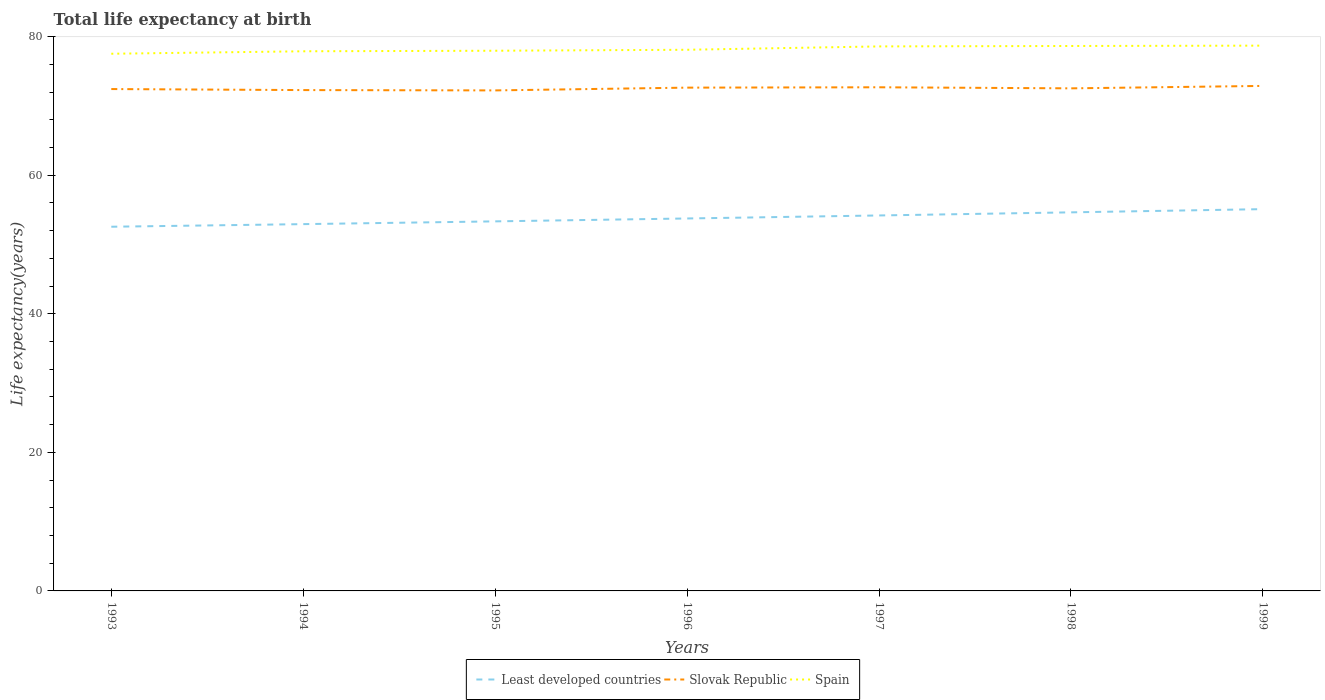Does the line corresponding to Slovak Republic intersect with the line corresponding to Least developed countries?
Give a very brief answer. No. Is the number of lines equal to the number of legend labels?
Your response must be concise. Yes. Across all years, what is the maximum life expectancy at birth in in Spain?
Your answer should be compact. 77.55. What is the total life expectancy at birth in in Least developed countries in the graph?
Make the answer very short. -1.77. What is the difference between the highest and the second highest life expectancy at birth in in Spain?
Offer a terse response. 1.17. Is the life expectancy at birth in in Spain strictly greater than the life expectancy at birth in in Least developed countries over the years?
Provide a short and direct response. No. How many lines are there?
Provide a succinct answer. 3. What is the difference between two consecutive major ticks on the Y-axis?
Keep it short and to the point. 20. How are the legend labels stacked?
Provide a short and direct response. Horizontal. What is the title of the graph?
Your answer should be very brief. Total life expectancy at birth. Does "Afghanistan" appear as one of the legend labels in the graph?
Keep it short and to the point. No. What is the label or title of the X-axis?
Ensure brevity in your answer.  Years. What is the label or title of the Y-axis?
Keep it short and to the point. Life expectancy(years). What is the Life expectancy(years) in Least developed countries in 1993?
Your answer should be very brief. 52.57. What is the Life expectancy(years) in Slovak Republic in 1993?
Offer a very short reply. 72.45. What is the Life expectancy(years) of Spain in 1993?
Your answer should be very brief. 77.55. What is the Life expectancy(years) in Least developed countries in 1994?
Give a very brief answer. 52.95. What is the Life expectancy(years) in Slovak Republic in 1994?
Your response must be concise. 72.3. What is the Life expectancy(years) in Spain in 1994?
Make the answer very short. 77.9. What is the Life expectancy(years) in Least developed countries in 1995?
Your answer should be compact. 53.35. What is the Life expectancy(years) of Slovak Republic in 1995?
Your answer should be compact. 72.25. What is the Life expectancy(years) of Spain in 1995?
Provide a short and direct response. 77.98. What is the Life expectancy(years) of Least developed countries in 1996?
Your response must be concise. 53.77. What is the Life expectancy(years) of Slovak Republic in 1996?
Your answer should be compact. 72.65. What is the Life expectancy(years) of Spain in 1996?
Make the answer very short. 78.12. What is the Life expectancy(years) of Least developed countries in 1997?
Provide a short and direct response. 54.2. What is the Life expectancy(years) of Slovak Republic in 1997?
Your response must be concise. 72.7. What is the Life expectancy(years) of Spain in 1997?
Your answer should be very brief. 78.6. What is the Life expectancy(years) in Least developed countries in 1998?
Your answer should be compact. 54.65. What is the Life expectancy(years) of Slovak Republic in 1998?
Your response must be concise. 72.55. What is the Life expectancy(years) of Spain in 1998?
Offer a terse response. 78.67. What is the Life expectancy(years) of Least developed countries in 1999?
Keep it short and to the point. 55.11. What is the Life expectancy(years) in Slovak Republic in 1999?
Ensure brevity in your answer.  72.9. What is the Life expectancy(years) in Spain in 1999?
Provide a succinct answer. 78.72. Across all years, what is the maximum Life expectancy(years) of Least developed countries?
Give a very brief answer. 55.11. Across all years, what is the maximum Life expectancy(years) of Slovak Republic?
Ensure brevity in your answer.  72.9. Across all years, what is the maximum Life expectancy(years) in Spain?
Ensure brevity in your answer.  78.72. Across all years, what is the minimum Life expectancy(years) of Least developed countries?
Your answer should be very brief. 52.57. Across all years, what is the minimum Life expectancy(years) of Slovak Republic?
Offer a very short reply. 72.25. Across all years, what is the minimum Life expectancy(years) of Spain?
Ensure brevity in your answer.  77.55. What is the total Life expectancy(years) in Least developed countries in the graph?
Ensure brevity in your answer.  376.6. What is the total Life expectancy(years) of Slovak Republic in the graph?
Offer a very short reply. 507.81. What is the total Life expectancy(years) of Spain in the graph?
Keep it short and to the point. 547.54. What is the difference between the Life expectancy(years) in Least developed countries in 1993 and that in 1994?
Your answer should be very brief. -0.38. What is the difference between the Life expectancy(years) in Slovak Republic in 1993 and that in 1994?
Give a very brief answer. 0.15. What is the difference between the Life expectancy(years) in Spain in 1993 and that in 1994?
Keep it short and to the point. -0.35. What is the difference between the Life expectancy(years) of Least developed countries in 1993 and that in 1995?
Keep it short and to the point. -0.77. What is the difference between the Life expectancy(years) in Slovak Republic in 1993 and that in 1995?
Your response must be concise. 0.2. What is the difference between the Life expectancy(years) of Spain in 1993 and that in 1995?
Your answer should be very brief. -0.43. What is the difference between the Life expectancy(years) in Least developed countries in 1993 and that in 1996?
Provide a succinct answer. -1.19. What is the difference between the Life expectancy(years) of Slovak Republic in 1993 and that in 1996?
Provide a succinct answer. -0.2. What is the difference between the Life expectancy(years) in Spain in 1993 and that in 1996?
Your response must be concise. -0.57. What is the difference between the Life expectancy(years) of Least developed countries in 1993 and that in 1997?
Offer a very short reply. -1.63. What is the difference between the Life expectancy(years) in Slovak Republic in 1993 and that in 1997?
Your answer should be compact. -0.26. What is the difference between the Life expectancy(years) of Spain in 1993 and that in 1997?
Your answer should be very brief. -1.06. What is the difference between the Life expectancy(years) in Least developed countries in 1993 and that in 1998?
Offer a very short reply. -2.08. What is the difference between the Life expectancy(years) of Slovak Republic in 1993 and that in 1998?
Ensure brevity in your answer.  -0.1. What is the difference between the Life expectancy(years) of Spain in 1993 and that in 1998?
Offer a terse response. -1.12. What is the difference between the Life expectancy(years) in Least developed countries in 1993 and that in 1999?
Give a very brief answer. -2.54. What is the difference between the Life expectancy(years) of Slovak Republic in 1993 and that in 1999?
Give a very brief answer. -0.45. What is the difference between the Life expectancy(years) in Spain in 1993 and that in 1999?
Provide a short and direct response. -1.17. What is the difference between the Life expectancy(years) of Least developed countries in 1994 and that in 1995?
Your answer should be very brief. -0.4. What is the difference between the Life expectancy(years) of Slovak Republic in 1994 and that in 1995?
Offer a very short reply. 0.05. What is the difference between the Life expectancy(years) in Spain in 1994 and that in 1995?
Ensure brevity in your answer.  -0.08. What is the difference between the Life expectancy(years) in Least developed countries in 1994 and that in 1996?
Offer a terse response. -0.82. What is the difference between the Life expectancy(years) of Slovak Republic in 1994 and that in 1996?
Your answer should be compact. -0.35. What is the difference between the Life expectancy(years) of Spain in 1994 and that in 1996?
Make the answer very short. -0.22. What is the difference between the Life expectancy(years) of Least developed countries in 1994 and that in 1997?
Give a very brief answer. -1.25. What is the difference between the Life expectancy(years) of Slovak Republic in 1994 and that in 1997?
Offer a very short reply. -0.4. What is the difference between the Life expectancy(years) of Spain in 1994 and that in 1997?
Offer a very short reply. -0.7. What is the difference between the Life expectancy(years) in Least developed countries in 1994 and that in 1998?
Your response must be concise. -1.7. What is the difference between the Life expectancy(years) in Slovak Republic in 1994 and that in 1998?
Provide a short and direct response. -0.25. What is the difference between the Life expectancy(years) in Spain in 1994 and that in 1998?
Ensure brevity in your answer.  -0.76. What is the difference between the Life expectancy(years) in Least developed countries in 1994 and that in 1999?
Keep it short and to the point. -2.16. What is the difference between the Life expectancy(years) of Slovak Republic in 1994 and that in 1999?
Offer a very short reply. -0.6. What is the difference between the Life expectancy(years) in Spain in 1994 and that in 1999?
Offer a very short reply. -0.82. What is the difference between the Life expectancy(years) in Least developed countries in 1995 and that in 1996?
Ensure brevity in your answer.  -0.42. What is the difference between the Life expectancy(years) of Spain in 1995 and that in 1996?
Your response must be concise. -0.14. What is the difference between the Life expectancy(years) in Least developed countries in 1995 and that in 1997?
Your answer should be very brief. -0.85. What is the difference between the Life expectancy(years) of Slovak Republic in 1995 and that in 1997?
Your answer should be compact. -0.45. What is the difference between the Life expectancy(years) of Spain in 1995 and that in 1997?
Provide a succinct answer. -0.62. What is the difference between the Life expectancy(years) in Least developed countries in 1995 and that in 1998?
Your response must be concise. -1.3. What is the difference between the Life expectancy(years) in Slovak Republic in 1995 and that in 1998?
Ensure brevity in your answer.  -0.3. What is the difference between the Life expectancy(years) of Spain in 1995 and that in 1998?
Ensure brevity in your answer.  -0.69. What is the difference between the Life expectancy(years) of Least developed countries in 1995 and that in 1999?
Your answer should be compact. -1.77. What is the difference between the Life expectancy(years) of Slovak Republic in 1995 and that in 1999?
Offer a very short reply. -0.65. What is the difference between the Life expectancy(years) of Spain in 1995 and that in 1999?
Ensure brevity in your answer.  -0.74. What is the difference between the Life expectancy(years) of Least developed countries in 1996 and that in 1997?
Offer a very short reply. -0.43. What is the difference between the Life expectancy(years) of Slovak Republic in 1996 and that in 1997?
Provide a short and direct response. -0.05. What is the difference between the Life expectancy(years) in Spain in 1996 and that in 1997?
Your response must be concise. -0.48. What is the difference between the Life expectancy(years) of Least developed countries in 1996 and that in 1998?
Keep it short and to the point. -0.88. What is the difference between the Life expectancy(years) in Slovak Republic in 1996 and that in 1998?
Make the answer very short. 0.1. What is the difference between the Life expectancy(years) in Spain in 1996 and that in 1998?
Keep it short and to the point. -0.55. What is the difference between the Life expectancy(years) in Least developed countries in 1996 and that in 1999?
Keep it short and to the point. -1.35. What is the difference between the Life expectancy(years) in Slovak Republic in 1996 and that in 1999?
Provide a succinct answer. -0.25. What is the difference between the Life expectancy(years) in Spain in 1996 and that in 1999?
Provide a succinct answer. -0.6. What is the difference between the Life expectancy(years) in Least developed countries in 1997 and that in 1998?
Make the answer very short. -0.45. What is the difference between the Life expectancy(years) of Slovak Republic in 1997 and that in 1998?
Make the answer very short. 0.15. What is the difference between the Life expectancy(years) of Spain in 1997 and that in 1998?
Offer a very short reply. -0.06. What is the difference between the Life expectancy(years) of Least developed countries in 1997 and that in 1999?
Offer a terse response. -0.91. What is the difference between the Life expectancy(years) in Slovak Republic in 1997 and that in 1999?
Give a very brief answer. -0.2. What is the difference between the Life expectancy(years) in Spain in 1997 and that in 1999?
Ensure brevity in your answer.  -0.11. What is the difference between the Life expectancy(years) of Least developed countries in 1998 and that in 1999?
Offer a terse response. -0.46. What is the difference between the Life expectancy(years) of Slovak Republic in 1998 and that in 1999?
Ensure brevity in your answer.  -0.35. What is the difference between the Life expectancy(years) in Spain in 1998 and that in 1999?
Offer a very short reply. -0.05. What is the difference between the Life expectancy(years) of Least developed countries in 1993 and the Life expectancy(years) of Slovak Republic in 1994?
Offer a very short reply. -19.73. What is the difference between the Life expectancy(years) of Least developed countries in 1993 and the Life expectancy(years) of Spain in 1994?
Your answer should be very brief. -25.33. What is the difference between the Life expectancy(years) in Slovak Republic in 1993 and the Life expectancy(years) in Spain in 1994?
Offer a terse response. -5.45. What is the difference between the Life expectancy(years) in Least developed countries in 1993 and the Life expectancy(years) in Slovak Republic in 1995?
Your answer should be compact. -19.68. What is the difference between the Life expectancy(years) of Least developed countries in 1993 and the Life expectancy(years) of Spain in 1995?
Provide a succinct answer. -25.41. What is the difference between the Life expectancy(years) in Slovak Republic in 1993 and the Life expectancy(years) in Spain in 1995?
Make the answer very short. -5.53. What is the difference between the Life expectancy(years) in Least developed countries in 1993 and the Life expectancy(years) in Slovak Republic in 1996?
Make the answer very short. -20.08. What is the difference between the Life expectancy(years) in Least developed countries in 1993 and the Life expectancy(years) in Spain in 1996?
Ensure brevity in your answer.  -25.55. What is the difference between the Life expectancy(years) in Slovak Republic in 1993 and the Life expectancy(years) in Spain in 1996?
Your answer should be very brief. -5.67. What is the difference between the Life expectancy(years) in Least developed countries in 1993 and the Life expectancy(years) in Slovak Republic in 1997?
Your response must be concise. -20.13. What is the difference between the Life expectancy(years) of Least developed countries in 1993 and the Life expectancy(years) of Spain in 1997?
Offer a terse response. -26.03. What is the difference between the Life expectancy(years) of Slovak Republic in 1993 and the Life expectancy(years) of Spain in 1997?
Keep it short and to the point. -6.16. What is the difference between the Life expectancy(years) in Least developed countries in 1993 and the Life expectancy(years) in Slovak Republic in 1998?
Your answer should be very brief. -19.98. What is the difference between the Life expectancy(years) of Least developed countries in 1993 and the Life expectancy(years) of Spain in 1998?
Give a very brief answer. -26.09. What is the difference between the Life expectancy(years) in Slovak Republic in 1993 and the Life expectancy(years) in Spain in 1998?
Your response must be concise. -6.22. What is the difference between the Life expectancy(years) of Least developed countries in 1993 and the Life expectancy(years) of Slovak Republic in 1999?
Offer a terse response. -20.33. What is the difference between the Life expectancy(years) of Least developed countries in 1993 and the Life expectancy(years) of Spain in 1999?
Keep it short and to the point. -26.14. What is the difference between the Life expectancy(years) in Slovak Republic in 1993 and the Life expectancy(years) in Spain in 1999?
Provide a succinct answer. -6.27. What is the difference between the Life expectancy(years) of Least developed countries in 1994 and the Life expectancy(years) of Slovak Republic in 1995?
Ensure brevity in your answer.  -19.3. What is the difference between the Life expectancy(years) of Least developed countries in 1994 and the Life expectancy(years) of Spain in 1995?
Keep it short and to the point. -25.03. What is the difference between the Life expectancy(years) of Slovak Republic in 1994 and the Life expectancy(years) of Spain in 1995?
Your answer should be compact. -5.68. What is the difference between the Life expectancy(years) in Least developed countries in 1994 and the Life expectancy(years) in Slovak Republic in 1996?
Give a very brief answer. -19.7. What is the difference between the Life expectancy(years) in Least developed countries in 1994 and the Life expectancy(years) in Spain in 1996?
Give a very brief answer. -25.17. What is the difference between the Life expectancy(years) of Slovak Republic in 1994 and the Life expectancy(years) of Spain in 1996?
Offer a very short reply. -5.82. What is the difference between the Life expectancy(years) in Least developed countries in 1994 and the Life expectancy(years) in Slovak Republic in 1997?
Your answer should be compact. -19.76. What is the difference between the Life expectancy(years) in Least developed countries in 1994 and the Life expectancy(years) in Spain in 1997?
Keep it short and to the point. -25.66. What is the difference between the Life expectancy(years) in Slovak Republic in 1994 and the Life expectancy(years) in Spain in 1997?
Your response must be concise. -6.3. What is the difference between the Life expectancy(years) in Least developed countries in 1994 and the Life expectancy(years) in Slovak Republic in 1998?
Ensure brevity in your answer.  -19.6. What is the difference between the Life expectancy(years) in Least developed countries in 1994 and the Life expectancy(years) in Spain in 1998?
Offer a terse response. -25.72. What is the difference between the Life expectancy(years) of Slovak Republic in 1994 and the Life expectancy(years) of Spain in 1998?
Give a very brief answer. -6.37. What is the difference between the Life expectancy(years) of Least developed countries in 1994 and the Life expectancy(years) of Slovak Republic in 1999?
Offer a very short reply. -19.95. What is the difference between the Life expectancy(years) in Least developed countries in 1994 and the Life expectancy(years) in Spain in 1999?
Offer a terse response. -25.77. What is the difference between the Life expectancy(years) of Slovak Republic in 1994 and the Life expectancy(years) of Spain in 1999?
Your answer should be compact. -6.42. What is the difference between the Life expectancy(years) in Least developed countries in 1995 and the Life expectancy(years) in Slovak Republic in 1996?
Your response must be concise. -19.31. What is the difference between the Life expectancy(years) in Least developed countries in 1995 and the Life expectancy(years) in Spain in 1996?
Give a very brief answer. -24.77. What is the difference between the Life expectancy(years) of Slovak Republic in 1995 and the Life expectancy(years) of Spain in 1996?
Provide a short and direct response. -5.87. What is the difference between the Life expectancy(years) of Least developed countries in 1995 and the Life expectancy(years) of Slovak Republic in 1997?
Make the answer very short. -19.36. What is the difference between the Life expectancy(years) in Least developed countries in 1995 and the Life expectancy(years) in Spain in 1997?
Keep it short and to the point. -25.26. What is the difference between the Life expectancy(years) in Slovak Republic in 1995 and the Life expectancy(years) in Spain in 1997?
Provide a short and direct response. -6.35. What is the difference between the Life expectancy(years) of Least developed countries in 1995 and the Life expectancy(years) of Slovak Republic in 1998?
Provide a succinct answer. -19.2. What is the difference between the Life expectancy(years) of Least developed countries in 1995 and the Life expectancy(years) of Spain in 1998?
Ensure brevity in your answer.  -25.32. What is the difference between the Life expectancy(years) in Slovak Republic in 1995 and the Life expectancy(years) in Spain in 1998?
Ensure brevity in your answer.  -6.41. What is the difference between the Life expectancy(years) of Least developed countries in 1995 and the Life expectancy(years) of Slovak Republic in 1999?
Give a very brief answer. -19.55. What is the difference between the Life expectancy(years) of Least developed countries in 1995 and the Life expectancy(years) of Spain in 1999?
Your answer should be compact. -25.37. What is the difference between the Life expectancy(years) in Slovak Republic in 1995 and the Life expectancy(years) in Spain in 1999?
Your response must be concise. -6.46. What is the difference between the Life expectancy(years) in Least developed countries in 1996 and the Life expectancy(years) in Slovak Republic in 1997?
Your answer should be compact. -18.94. What is the difference between the Life expectancy(years) of Least developed countries in 1996 and the Life expectancy(years) of Spain in 1997?
Make the answer very short. -24.84. What is the difference between the Life expectancy(years) in Slovak Republic in 1996 and the Life expectancy(years) in Spain in 1997?
Your answer should be very brief. -5.95. What is the difference between the Life expectancy(years) of Least developed countries in 1996 and the Life expectancy(years) of Slovak Republic in 1998?
Provide a short and direct response. -18.78. What is the difference between the Life expectancy(years) of Least developed countries in 1996 and the Life expectancy(years) of Spain in 1998?
Provide a succinct answer. -24.9. What is the difference between the Life expectancy(years) of Slovak Republic in 1996 and the Life expectancy(years) of Spain in 1998?
Provide a succinct answer. -6.01. What is the difference between the Life expectancy(years) in Least developed countries in 1996 and the Life expectancy(years) in Slovak Republic in 1999?
Your answer should be very brief. -19.14. What is the difference between the Life expectancy(years) in Least developed countries in 1996 and the Life expectancy(years) in Spain in 1999?
Offer a very short reply. -24.95. What is the difference between the Life expectancy(years) in Slovak Republic in 1996 and the Life expectancy(years) in Spain in 1999?
Offer a very short reply. -6.06. What is the difference between the Life expectancy(years) in Least developed countries in 1997 and the Life expectancy(years) in Slovak Republic in 1998?
Your answer should be very brief. -18.35. What is the difference between the Life expectancy(years) of Least developed countries in 1997 and the Life expectancy(years) of Spain in 1998?
Your answer should be compact. -24.46. What is the difference between the Life expectancy(years) of Slovak Republic in 1997 and the Life expectancy(years) of Spain in 1998?
Ensure brevity in your answer.  -5.96. What is the difference between the Life expectancy(years) in Least developed countries in 1997 and the Life expectancy(years) in Slovak Republic in 1999?
Offer a very short reply. -18.7. What is the difference between the Life expectancy(years) of Least developed countries in 1997 and the Life expectancy(years) of Spain in 1999?
Your response must be concise. -24.52. What is the difference between the Life expectancy(years) of Slovak Republic in 1997 and the Life expectancy(years) of Spain in 1999?
Provide a short and direct response. -6.01. What is the difference between the Life expectancy(years) in Least developed countries in 1998 and the Life expectancy(years) in Slovak Republic in 1999?
Provide a short and direct response. -18.25. What is the difference between the Life expectancy(years) in Least developed countries in 1998 and the Life expectancy(years) in Spain in 1999?
Your answer should be compact. -24.07. What is the difference between the Life expectancy(years) in Slovak Republic in 1998 and the Life expectancy(years) in Spain in 1999?
Make the answer very short. -6.17. What is the average Life expectancy(years) in Least developed countries per year?
Give a very brief answer. 53.8. What is the average Life expectancy(years) in Slovak Republic per year?
Provide a succinct answer. 72.54. What is the average Life expectancy(years) of Spain per year?
Your answer should be compact. 78.22. In the year 1993, what is the difference between the Life expectancy(years) in Least developed countries and Life expectancy(years) in Slovak Republic?
Make the answer very short. -19.88. In the year 1993, what is the difference between the Life expectancy(years) of Least developed countries and Life expectancy(years) of Spain?
Your answer should be very brief. -24.97. In the year 1993, what is the difference between the Life expectancy(years) of Slovak Republic and Life expectancy(years) of Spain?
Keep it short and to the point. -5.1. In the year 1994, what is the difference between the Life expectancy(years) in Least developed countries and Life expectancy(years) in Slovak Republic?
Provide a succinct answer. -19.35. In the year 1994, what is the difference between the Life expectancy(years) in Least developed countries and Life expectancy(years) in Spain?
Your answer should be compact. -24.95. In the year 1994, what is the difference between the Life expectancy(years) in Slovak Republic and Life expectancy(years) in Spain?
Make the answer very short. -5.6. In the year 1995, what is the difference between the Life expectancy(years) of Least developed countries and Life expectancy(years) of Slovak Republic?
Your answer should be very brief. -18.91. In the year 1995, what is the difference between the Life expectancy(years) in Least developed countries and Life expectancy(years) in Spain?
Your answer should be very brief. -24.63. In the year 1995, what is the difference between the Life expectancy(years) of Slovak Republic and Life expectancy(years) of Spain?
Your answer should be very brief. -5.73. In the year 1996, what is the difference between the Life expectancy(years) in Least developed countries and Life expectancy(years) in Slovak Republic?
Offer a terse response. -18.89. In the year 1996, what is the difference between the Life expectancy(years) in Least developed countries and Life expectancy(years) in Spain?
Keep it short and to the point. -24.35. In the year 1996, what is the difference between the Life expectancy(years) of Slovak Republic and Life expectancy(years) of Spain?
Keep it short and to the point. -5.47. In the year 1997, what is the difference between the Life expectancy(years) of Least developed countries and Life expectancy(years) of Slovak Republic?
Make the answer very short. -18.5. In the year 1997, what is the difference between the Life expectancy(years) of Least developed countries and Life expectancy(years) of Spain?
Your response must be concise. -24.4. In the year 1997, what is the difference between the Life expectancy(years) in Slovak Republic and Life expectancy(years) in Spain?
Provide a succinct answer. -5.9. In the year 1998, what is the difference between the Life expectancy(years) of Least developed countries and Life expectancy(years) of Slovak Republic?
Ensure brevity in your answer.  -17.9. In the year 1998, what is the difference between the Life expectancy(years) of Least developed countries and Life expectancy(years) of Spain?
Offer a terse response. -24.02. In the year 1998, what is the difference between the Life expectancy(years) in Slovak Republic and Life expectancy(years) in Spain?
Make the answer very short. -6.11. In the year 1999, what is the difference between the Life expectancy(years) in Least developed countries and Life expectancy(years) in Slovak Republic?
Your answer should be compact. -17.79. In the year 1999, what is the difference between the Life expectancy(years) in Least developed countries and Life expectancy(years) in Spain?
Give a very brief answer. -23.6. In the year 1999, what is the difference between the Life expectancy(years) in Slovak Republic and Life expectancy(years) in Spain?
Give a very brief answer. -5.81. What is the ratio of the Life expectancy(years) of Least developed countries in 1993 to that in 1994?
Provide a succinct answer. 0.99. What is the ratio of the Life expectancy(years) of Spain in 1993 to that in 1994?
Your answer should be very brief. 1. What is the ratio of the Life expectancy(years) of Least developed countries in 1993 to that in 1995?
Offer a very short reply. 0.99. What is the ratio of the Life expectancy(years) of Least developed countries in 1993 to that in 1996?
Keep it short and to the point. 0.98. What is the ratio of the Life expectancy(years) of Slovak Republic in 1993 to that in 1996?
Offer a terse response. 1. What is the ratio of the Life expectancy(years) in Spain in 1993 to that in 1996?
Provide a succinct answer. 0.99. What is the ratio of the Life expectancy(years) of Least developed countries in 1993 to that in 1997?
Give a very brief answer. 0.97. What is the ratio of the Life expectancy(years) in Spain in 1993 to that in 1997?
Provide a succinct answer. 0.99. What is the ratio of the Life expectancy(years) in Least developed countries in 1993 to that in 1998?
Ensure brevity in your answer.  0.96. What is the ratio of the Life expectancy(years) of Slovak Republic in 1993 to that in 1998?
Keep it short and to the point. 1. What is the ratio of the Life expectancy(years) of Spain in 1993 to that in 1998?
Offer a very short reply. 0.99. What is the ratio of the Life expectancy(years) of Least developed countries in 1993 to that in 1999?
Your response must be concise. 0.95. What is the ratio of the Life expectancy(years) in Slovak Republic in 1993 to that in 1999?
Your answer should be very brief. 0.99. What is the ratio of the Life expectancy(years) of Spain in 1993 to that in 1999?
Your answer should be very brief. 0.99. What is the ratio of the Life expectancy(years) in Least developed countries in 1994 to that in 1996?
Your response must be concise. 0.98. What is the ratio of the Life expectancy(years) in Slovak Republic in 1994 to that in 1996?
Ensure brevity in your answer.  1. What is the ratio of the Life expectancy(years) in Spain in 1994 to that in 1996?
Make the answer very short. 1. What is the ratio of the Life expectancy(years) of Least developed countries in 1994 to that in 1997?
Make the answer very short. 0.98. What is the ratio of the Life expectancy(years) of Slovak Republic in 1994 to that in 1997?
Provide a short and direct response. 0.99. What is the ratio of the Life expectancy(years) in Spain in 1994 to that in 1997?
Make the answer very short. 0.99. What is the ratio of the Life expectancy(years) of Least developed countries in 1994 to that in 1998?
Offer a terse response. 0.97. What is the ratio of the Life expectancy(years) of Spain in 1994 to that in 1998?
Your answer should be compact. 0.99. What is the ratio of the Life expectancy(years) of Least developed countries in 1994 to that in 1999?
Offer a very short reply. 0.96. What is the ratio of the Life expectancy(years) in Slovak Republic in 1994 to that in 1999?
Give a very brief answer. 0.99. What is the ratio of the Life expectancy(years) in Spain in 1995 to that in 1996?
Make the answer very short. 1. What is the ratio of the Life expectancy(years) in Least developed countries in 1995 to that in 1997?
Keep it short and to the point. 0.98. What is the ratio of the Life expectancy(years) of Least developed countries in 1995 to that in 1998?
Your response must be concise. 0.98. What is the ratio of the Life expectancy(years) of Least developed countries in 1995 to that in 1999?
Offer a very short reply. 0.97. What is the ratio of the Life expectancy(years) of Slovak Republic in 1995 to that in 1999?
Ensure brevity in your answer.  0.99. What is the ratio of the Life expectancy(years) of Spain in 1995 to that in 1999?
Keep it short and to the point. 0.99. What is the ratio of the Life expectancy(years) in Slovak Republic in 1996 to that in 1997?
Ensure brevity in your answer.  1. What is the ratio of the Life expectancy(years) of Spain in 1996 to that in 1997?
Ensure brevity in your answer.  0.99. What is the ratio of the Life expectancy(years) of Least developed countries in 1996 to that in 1998?
Provide a short and direct response. 0.98. What is the ratio of the Life expectancy(years) in Slovak Republic in 1996 to that in 1998?
Provide a short and direct response. 1. What is the ratio of the Life expectancy(years) in Least developed countries in 1996 to that in 1999?
Provide a short and direct response. 0.98. What is the ratio of the Life expectancy(years) of Least developed countries in 1997 to that in 1999?
Your response must be concise. 0.98. What is the ratio of the Life expectancy(years) of Spain in 1997 to that in 1999?
Make the answer very short. 1. What is the ratio of the Life expectancy(years) of Least developed countries in 1998 to that in 1999?
Your answer should be very brief. 0.99. What is the ratio of the Life expectancy(years) of Slovak Republic in 1998 to that in 1999?
Provide a succinct answer. 1. What is the difference between the highest and the second highest Life expectancy(years) of Least developed countries?
Provide a succinct answer. 0.46. What is the difference between the highest and the second highest Life expectancy(years) in Slovak Republic?
Your response must be concise. 0.2. What is the difference between the highest and the second highest Life expectancy(years) in Spain?
Keep it short and to the point. 0.05. What is the difference between the highest and the lowest Life expectancy(years) in Least developed countries?
Your response must be concise. 2.54. What is the difference between the highest and the lowest Life expectancy(years) in Slovak Republic?
Keep it short and to the point. 0.65. What is the difference between the highest and the lowest Life expectancy(years) of Spain?
Ensure brevity in your answer.  1.17. 